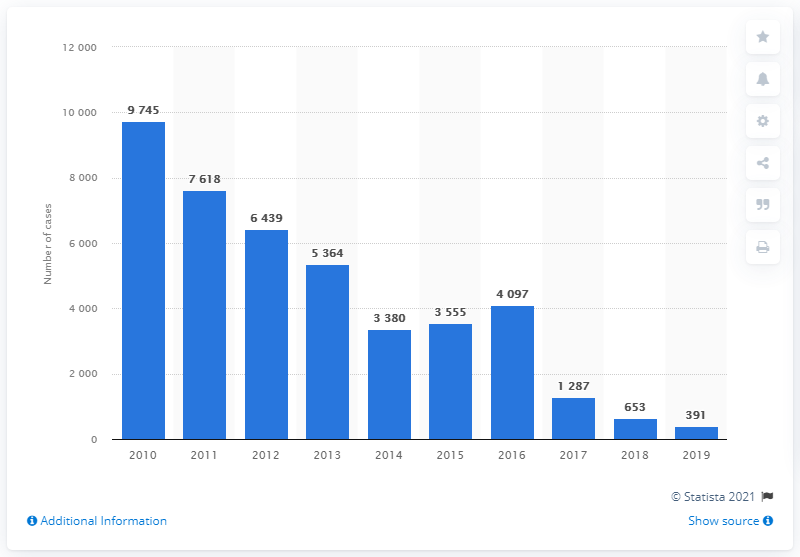Draw attention to some important aspects in this diagram. In 2019, a total of 391 cases of malaria were reported in Honduras. 